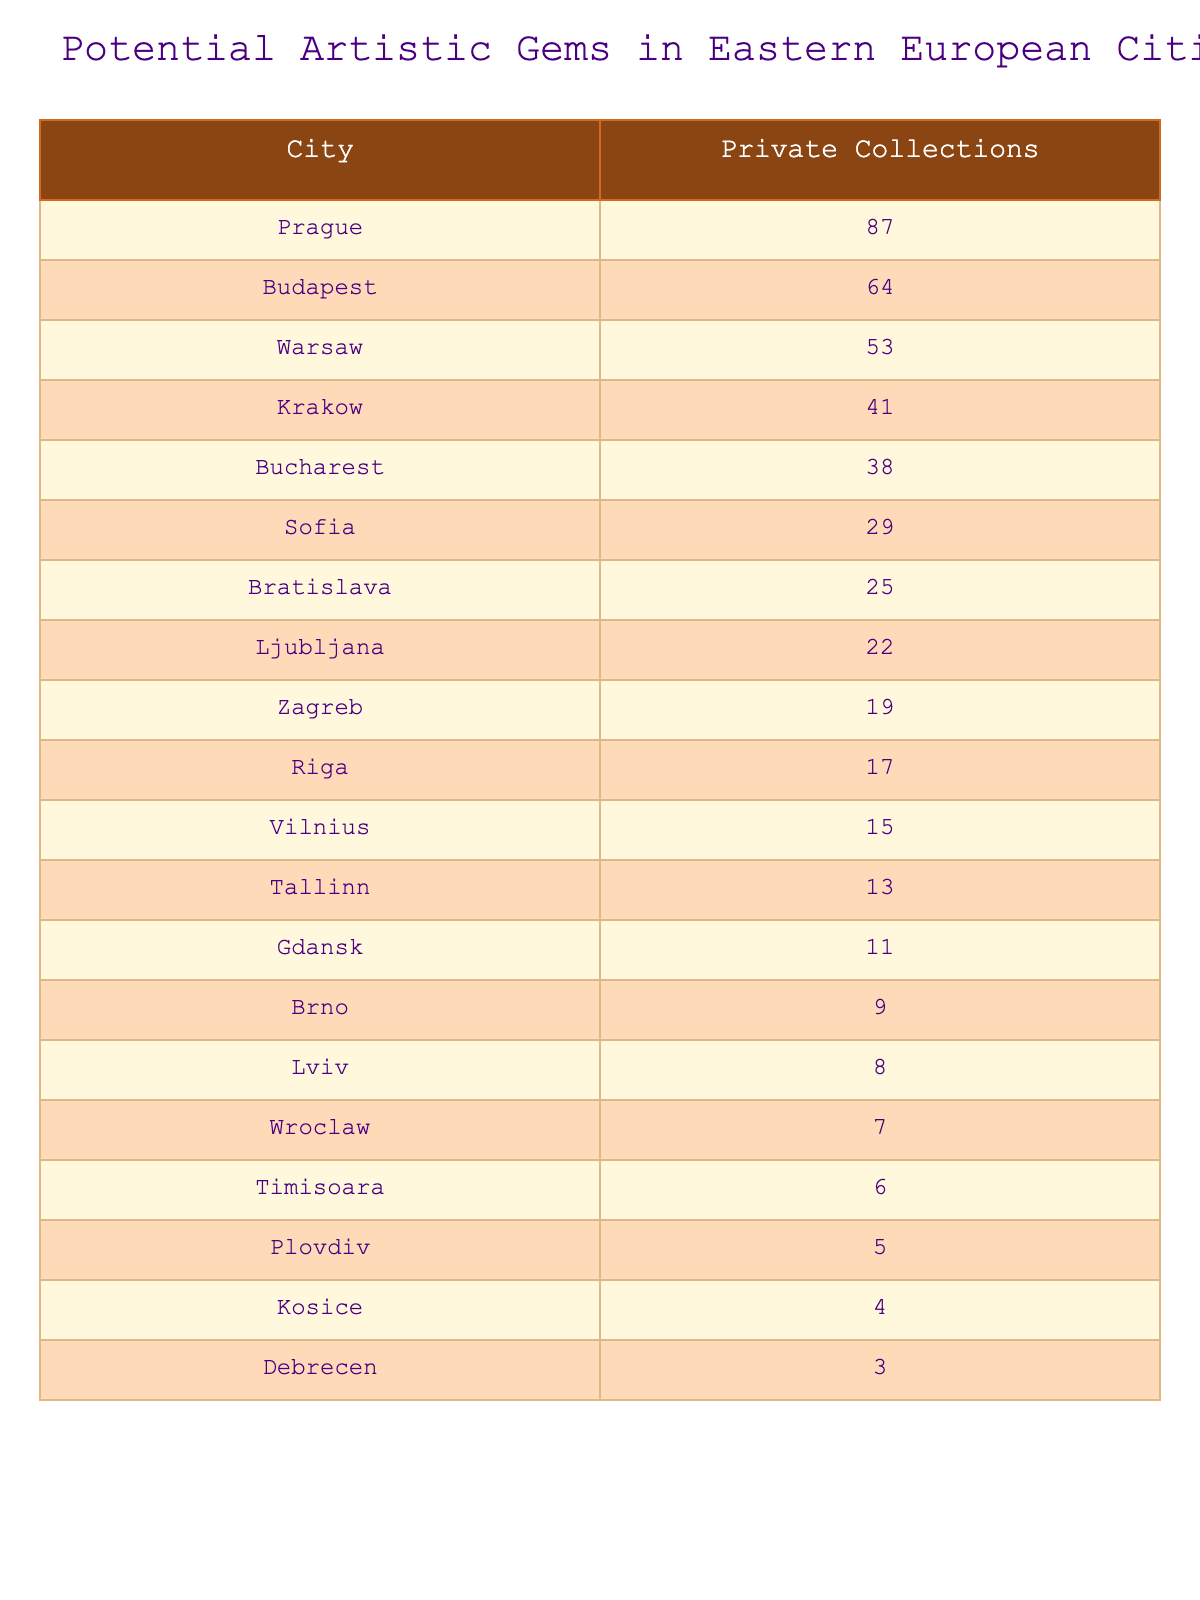What city has the highest number of private collections? By examining the "Private Collections" column, it is clear that Prague has the highest value at 87 collections.
Answer: Prague How many private collections are there in Budapest? The table shows that Budapest has a total of 64 private collections.
Answer: 64 What is the difference in the number of private collections between Warsaw and Krakow? Warsaw has 53 collections, and Krakow has 41 collections. The difference is calculated as 53 - 41 = 12.
Answer: 12 Which city has fewer private collections, Lviv or Wroclaw? Lviv has 8 collections, and Wroclaw has 7 collections. Since 7 is less than 8, Wroclaw has fewer collections.
Answer: Wroclaw What is the total number of private collections in the top three cities? The top three cities are Prague (87), Budapest (64), and Warsaw (53). Summing these values gives us 87 + 64 + 53 = 204.
Answer: 204 Is it true that Sofia has more private collections than Bucharest? Sofia has 29 collections, while Bucharest has 38 collections. Since 29 is less than 38, the statement is false.
Answer: False What is the average number of private collections among the cities listed? To find the average, sum all the collections: 87 + 64 + 53 + 41 + 38 + 29 + 25 + 22 + 19 + 17 + 15 + 13 + 11 + 9 + 8 + 7 + 6 + 5 + 4 + 3 = 453. There are 20 cities, so the average is 453 / 20 = 22.65 (rounded to two decimal places).
Answer: 22.65 Which city ranks fifth in terms of private collections? Counting from the highest, the fifth city is Bucharest with 38 collections.
Answer: Bucharest What is the sum of private collections for the last five cities on the list? The last five cities are Wroclaw (7), Timisoara (6), Plovdiv (5), Kosice (4), and Debrecen (3). Summing these values gives 7 + 6 + 5 + 4 + 3 = 25.
Answer: 25 If we combine the private collections of the top two cities, how many do we have? The top two cities are Prague (87) and Budapest (64). Combining these gives 87 + 64 = 151.
Answer: 151 